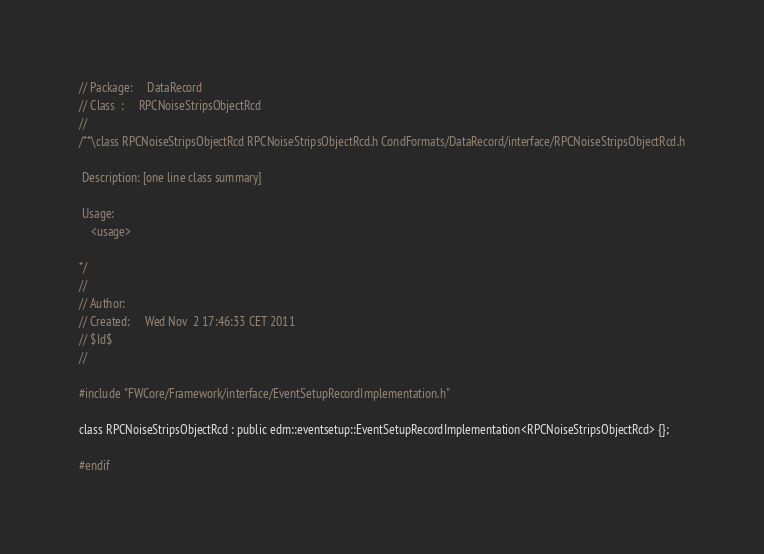Convert code to text. <code><loc_0><loc_0><loc_500><loc_500><_C_>// Package:     DataRecord
// Class  :     RPCNoiseStripsObjectRcd
//
/**\class RPCNoiseStripsObjectRcd RPCNoiseStripsObjectRcd.h CondFormats/DataRecord/interface/RPCNoiseStripsObjectRcd.h

 Description: [one line class summary]

 Usage:
    <usage>

*/
//
// Author:
// Created:     Wed Nov  2 17:46:33 CET 2011
// $Id$
//

#include "FWCore/Framework/interface/EventSetupRecordImplementation.h"

class RPCNoiseStripsObjectRcd : public edm::eventsetup::EventSetupRecordImplementation<RPCNoiseStripsObjectRcd> {};

#endif
</code> 